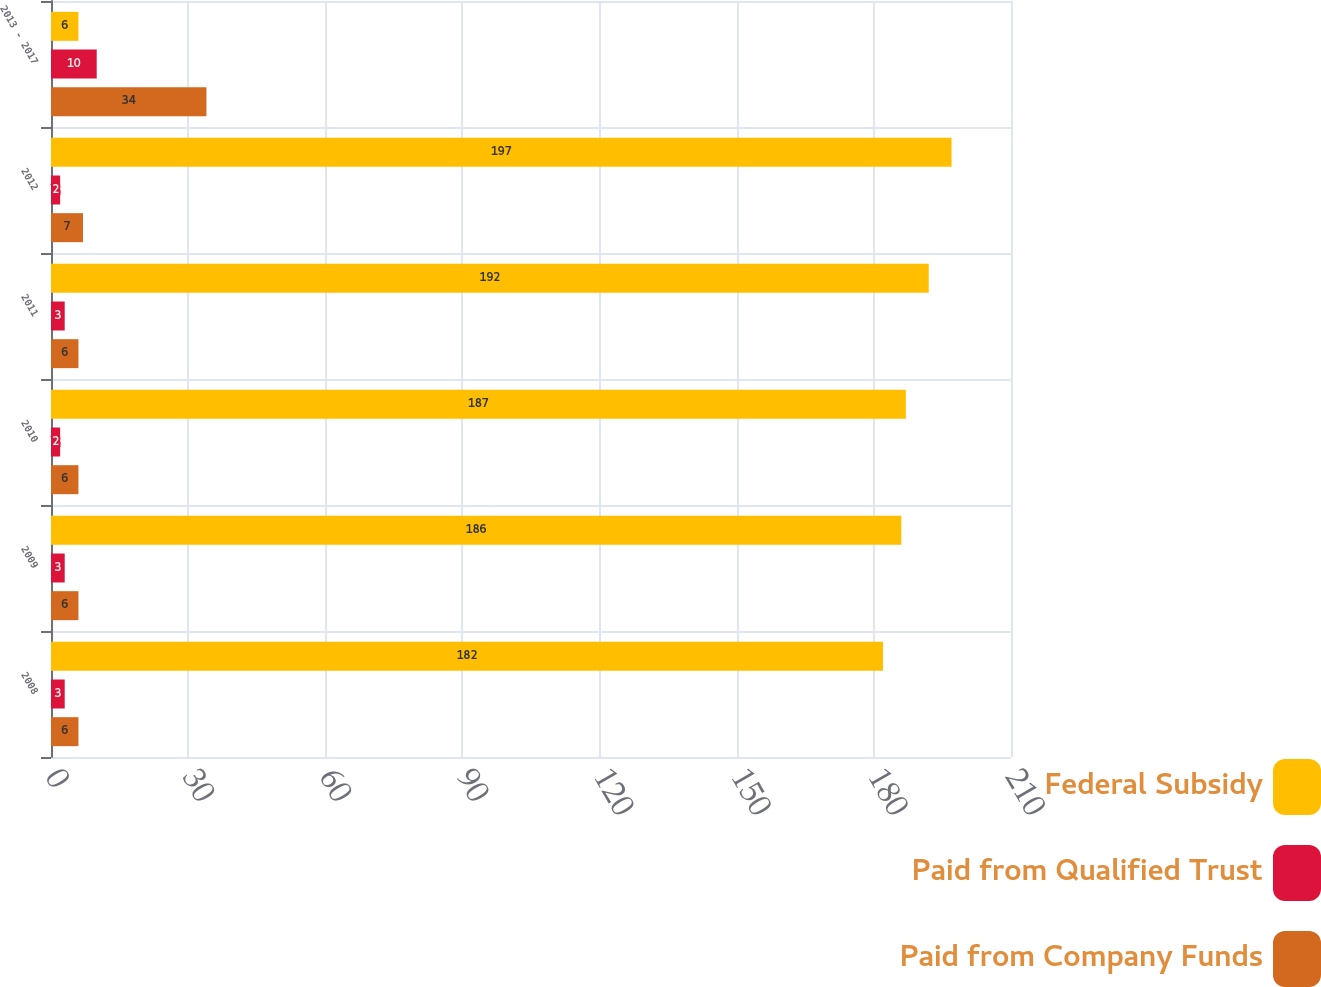Convert chart. <chart><loc_0><loc_0><loc_500><loc_500><stacked_bar_chart><ecel><fcel>2008<fcel>2009<fcel>2010<fcel>2011<fcel>2012<fcel>2013 - 2017<nl><fcel>Federal Subsidy<fcel>182<fcel>186<fcel>187<fcel>192<fcel>197<fcel>6<nl><fcel>Paid from Qualified Trust<fcel>3<fcel>3<fcel>2<fcel>3<fcel>2<fcel>10<nl><fcel>Paid from Company Funds<fcel>6<fcel>6<fcel>6<fcel>6<fcel>7<fcel>34<nl></chart> 